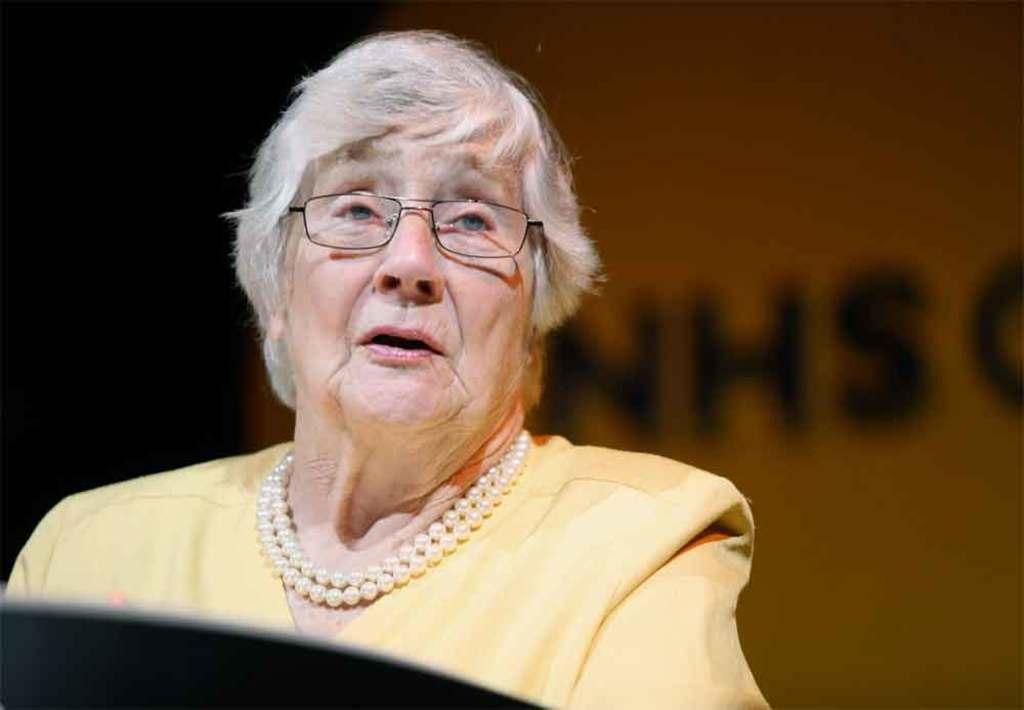Who is present in the image? There is a woman in the image. What is the woman wearing? The woman is wearing a yellow dress and glasses (specs). What can be seen in the background of the image? There is a banner in the background of the image. What type of potato is being discovered in the image? There is no potato or discovery present in the image; it features a woman wearing a yellow dress and glasses, with a banner in the background. 